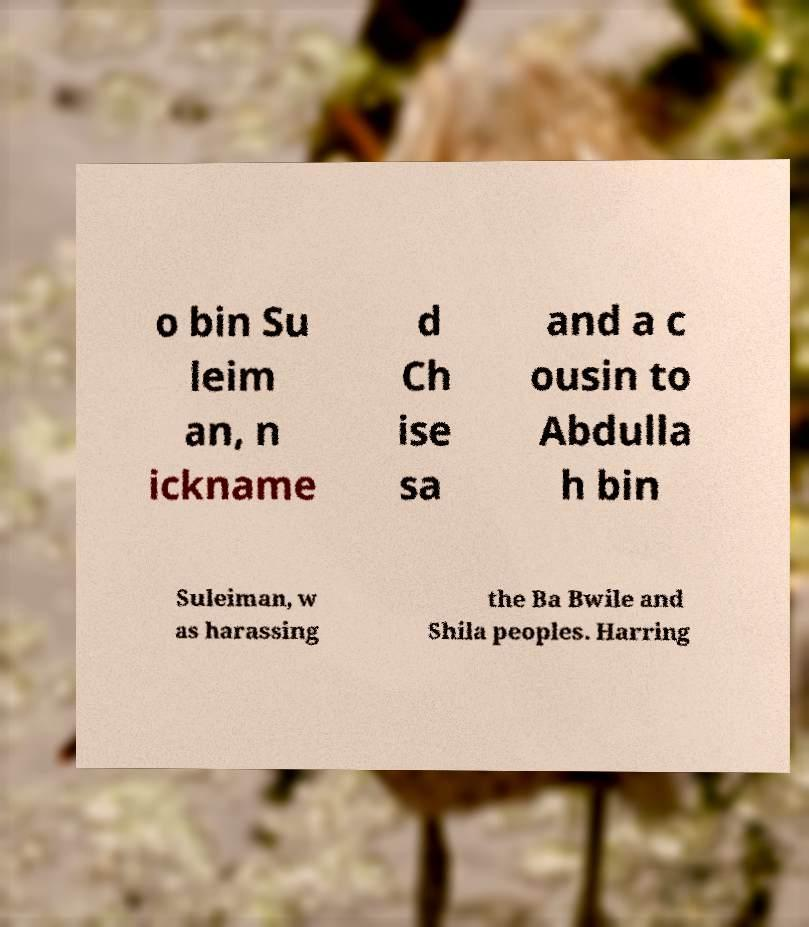Please read and relay the text visible in this image. What does it say? o bin Su leim an, n ickname d Ch ise sa and a c ousin to Abdulla h bin Suleiman, w as harassing the Ba Bwile and Shila peoples. Harring 